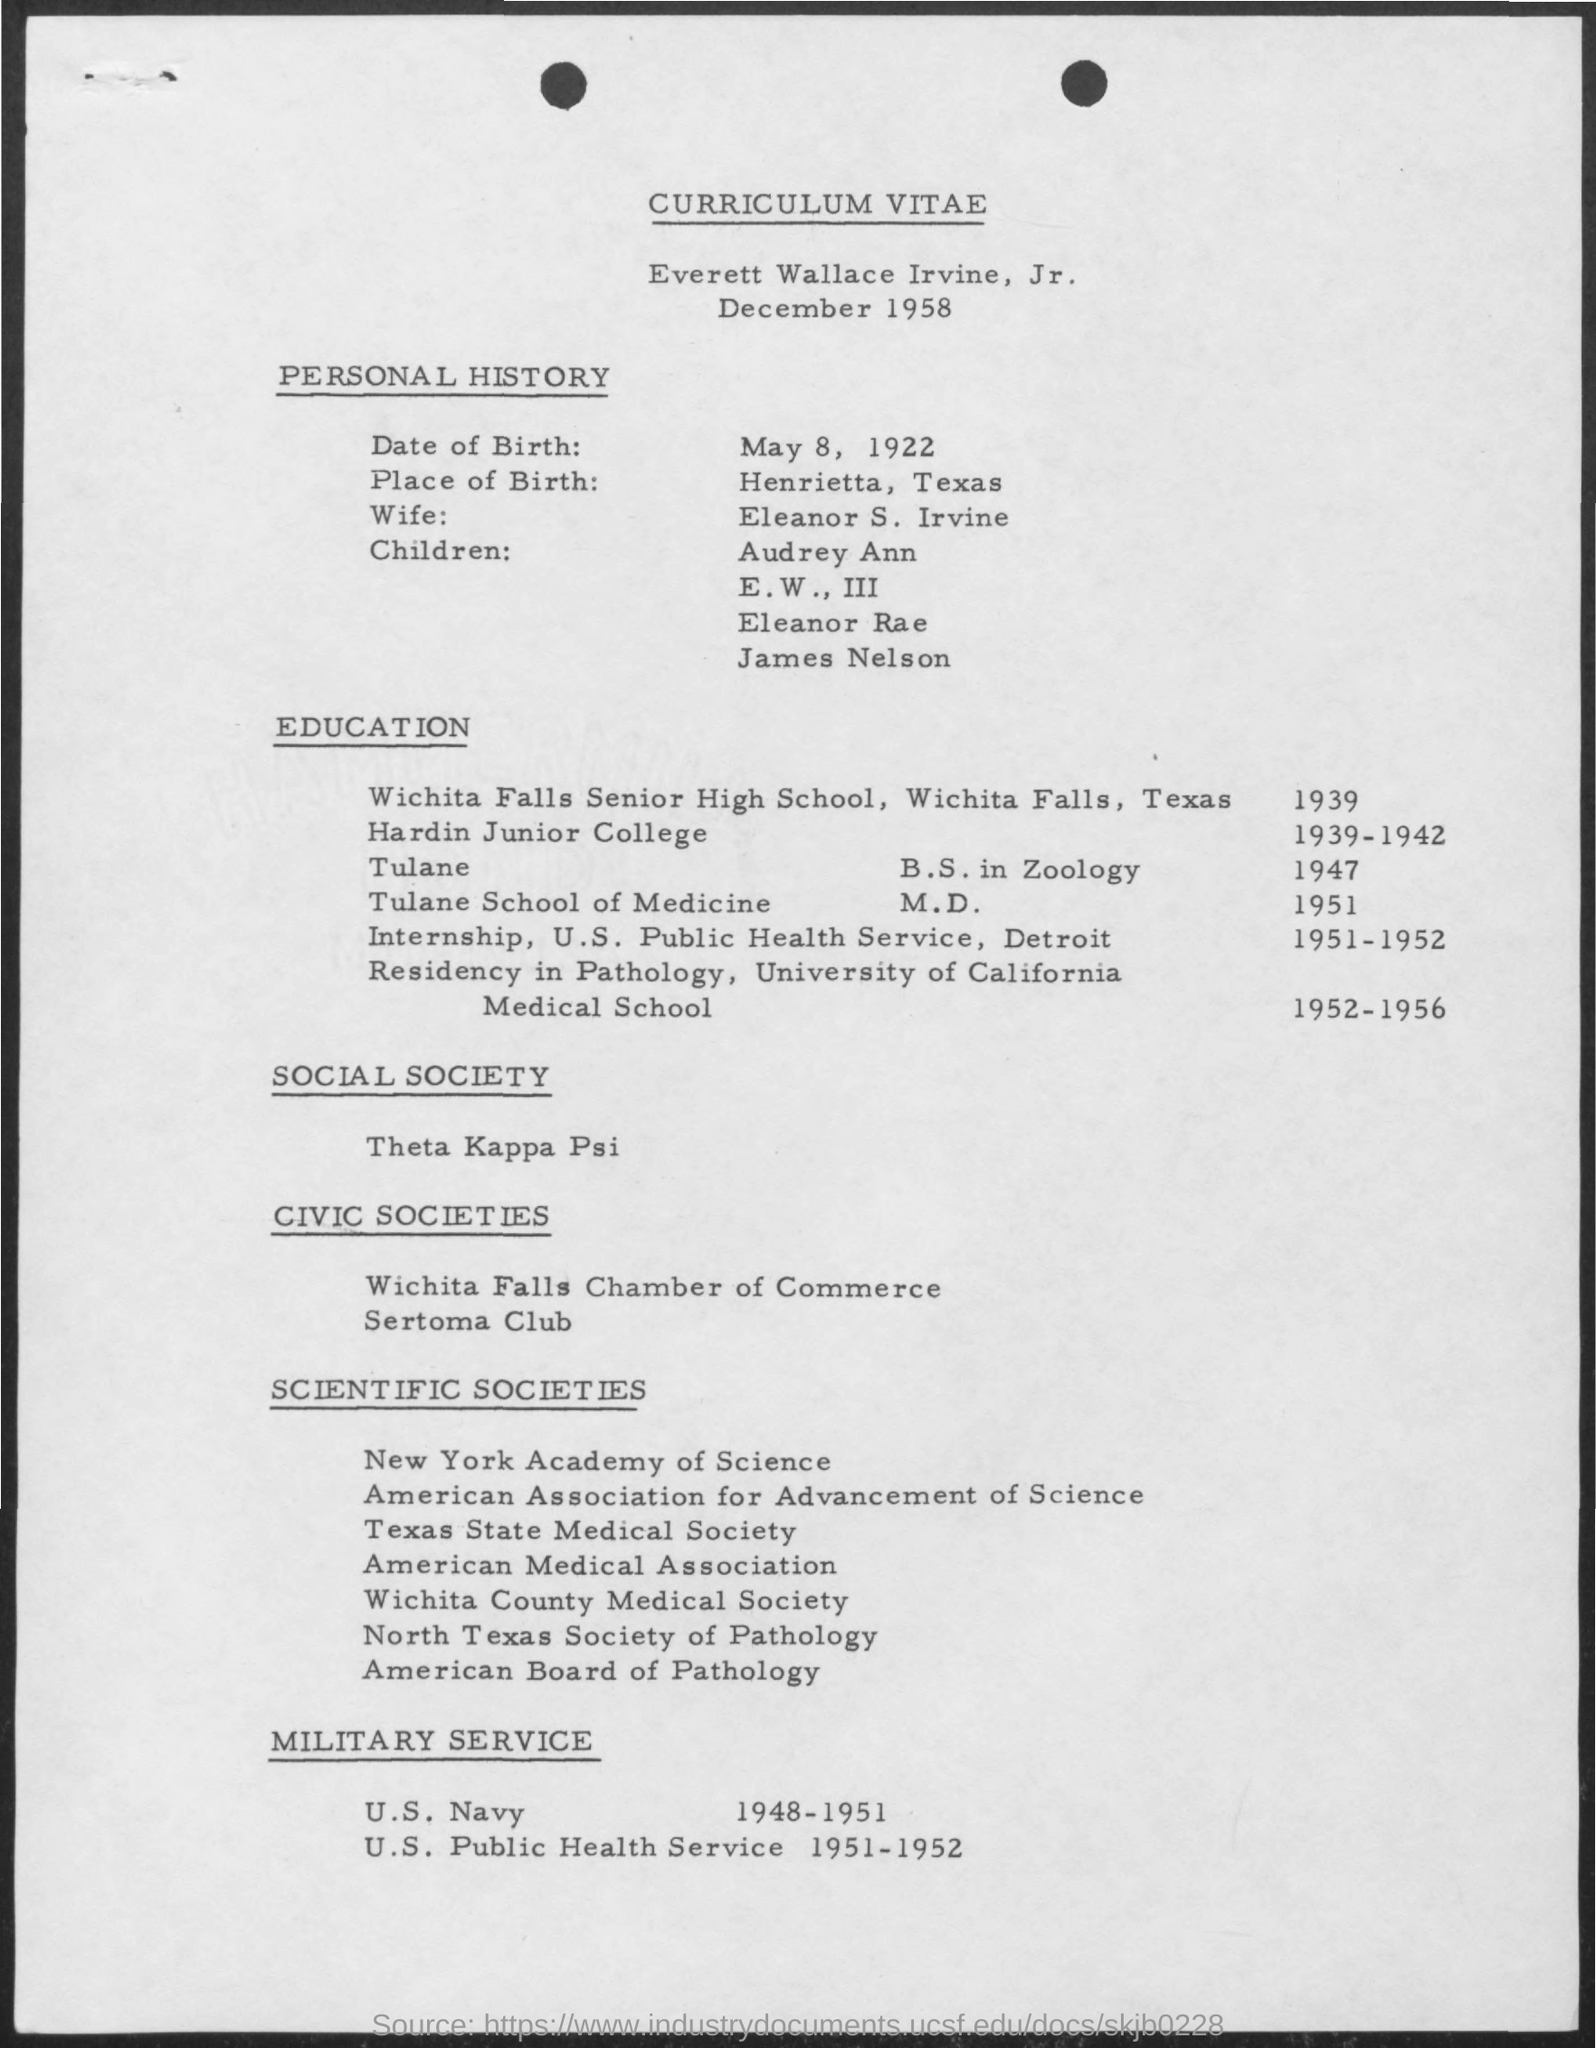To whom this curriculum vitae belongs to ?
Ensure brevity in your answer.  Everett Wallace Irvine,Jr. What is the date of birth mentioned in the given curriculum vitae ?
Your response must be concise. May 8, 1922. What is the place of birth mentioned in the given curriculum vitae ?
Offer a terse response. Henrietta , Texas. What is the name of the wife as mentioned in the curriculum vitae ?
Provide a succinct answer. Eleanor s. irvine. In which year he studied in wichita falls senior high school?
Provide a succinct answer. 1939. In which year he studies in hardin junior college as given in the curriculum vitae ?
Give a very brief answer. 1939-1942. In which year everett wallace irvine .jr completed his m.d in tulane school of medicine ?
Offer a terse response. 1951. In which years he done his internship as given in the curriculum vitae ?
Offer a very short reply. 1951-1952. During which years everett wallace irvine,jr done the military service in u.s. navy ?
Offer a very short reply. 1948-1951. 